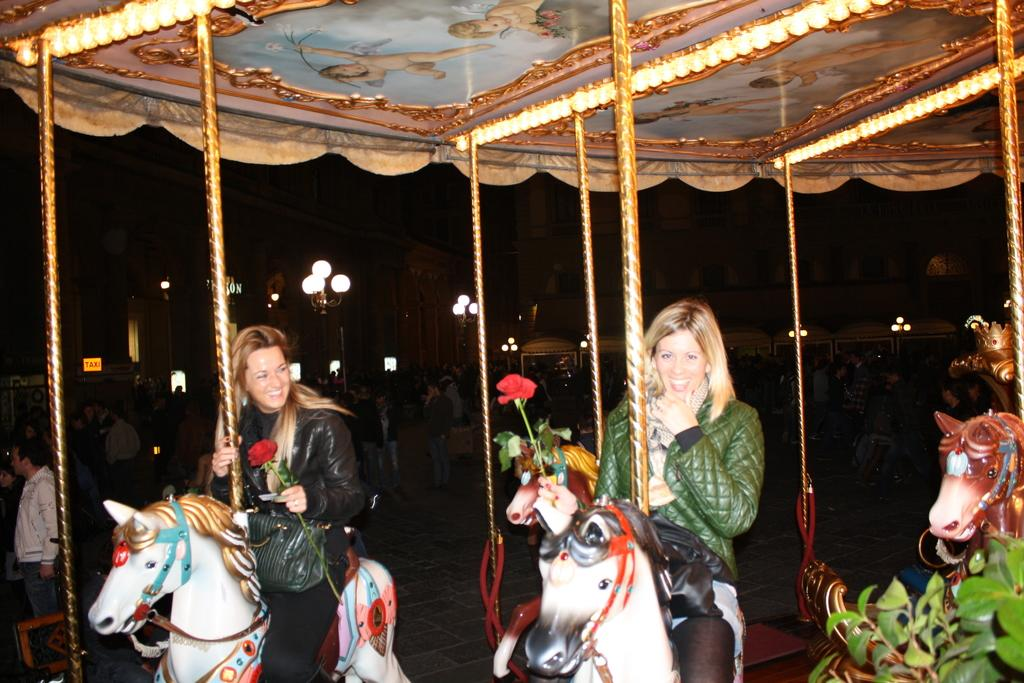How many women are in the image? There are two women in the image. What are the women doing in the image? The women are sitting on a horse doll. What are the women holding in their hands? The women are holding rose flowers in their hands. What can be seen in the background of the image? There is a group of people visible in the background. What is the source of illumination in the image? There are lights present in the image. What type of waste is being disposed of in the image? There is no waste present in the image; it features two women sitting on a horse doll and holding rose flowers. What type of property is visible in the image? The image does not show any specific property; it focuses on the two women and their surroundings. 